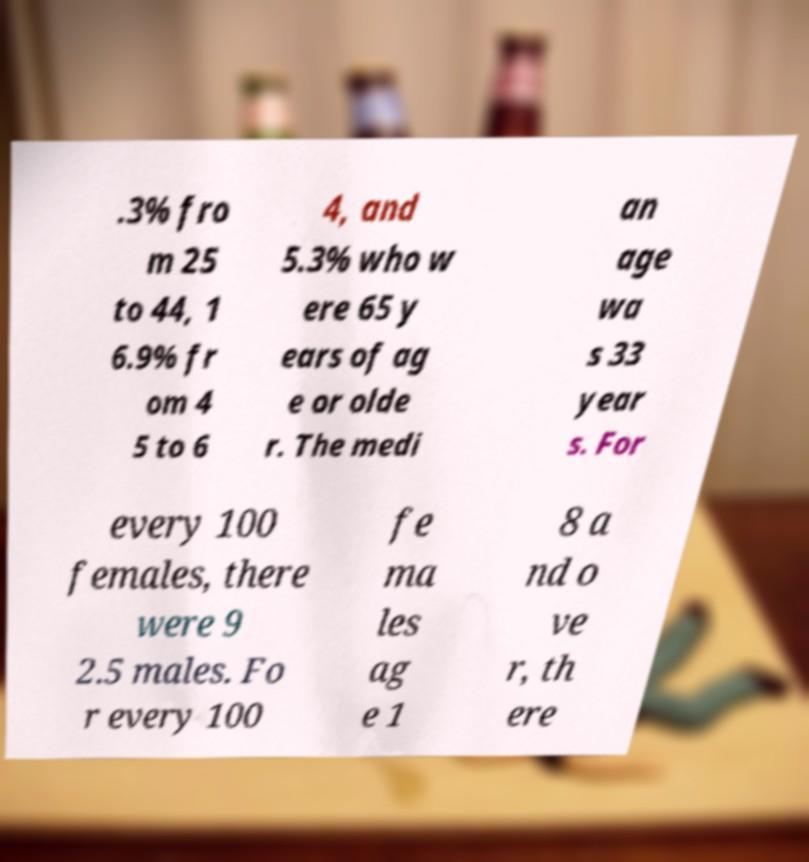Please identify and transcribe the text found in this image. .3% fro m 25 to 44, 1 6.9% fr om 4 5 to 6 4, and 5.3% who w ere 65 y ears of ag e or olde r. The medi an age wa s 33 year s. For every 100 females, there were 9 2.5 males. Fo r every 100 fe ma les ag e 1 8 a nd o ve r, th ere 